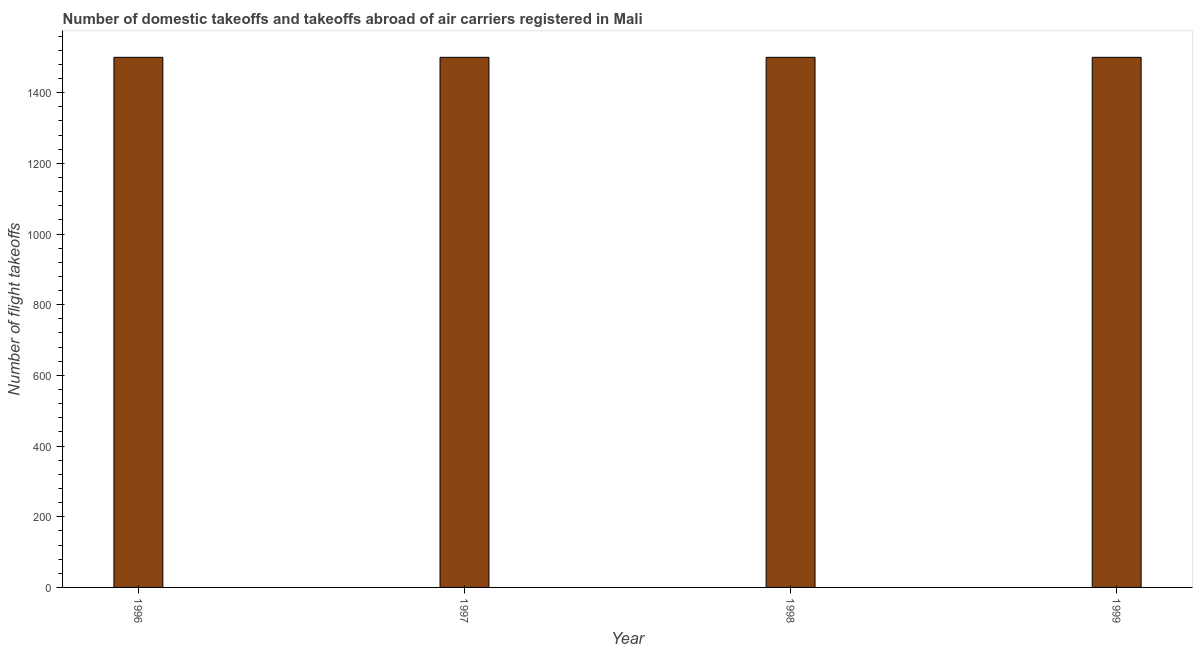Does the graph contain any zero values?
Ensure brevity in your answer.  No. What is the title of the graph?
Provide a short and direct response. Number of domestic takeoffs and takeoffs abroad of air carriers registered in Mali. What is the label or title of the X-axis?
Provide a short and direct response. Year. What is the label or title of the Y-axis?
Provide a short and direct response. Number of flight takeoffs. What is the number of flight takeoffs in 1998?
Keep it short and to the point. 1500. Across all years, what is the maximum number of flight takeoffs?
Your answer should be compact. 1500. Across all years, what is the minimum number of flight takeoffs?
Provide a succinct answer. 1500. In which year was the number of flight takeoffs minimum?
Provide a succinct answer. 1996. What is the sum of the number of flight takeoffs?
Give a very brief answer. 6000. What is the difference between the number of flight takeoffs in 1997 and 1999?
Give a very brief answer. 0. What is the average number of flight takeoffs per year?
Offer a very short reply. 1500. What is the median number of flight takeoffs?
Your answer should be very brief. 1500. Do a majority of the years between 1998 and 1996 (inclusive) have number of flight takeoffs greater than 40 ?
Keep it short and to the point. Yes. Is the number of flight takeoffs in 1996 less than that in 1997?
Your answer should be compact. No. Is the difference between the number of flight takeoffs in 1997 and 1999 greater than the difference between any two years?
Make the answer very short. Yes. What is the difference between the highest and the second highest number of flight takeoffs?
Offer a very short reply. 0. Is the sum of the number of flight takeoffs in 1996 and 1998 greater than the maximum number of flight takeoffs across all years?
Offer a terse response. Yes. What is the difference between the highest and the lowest number of flight takeoffs?
Give a very brief answer. 0. In how many years, is the number of flight takeoffs greater than the average number of flight takeoffs taken over all years?
Make the answer very short. 0. How many years are there in the graph?
Keep it short and to the point. 4. Are the values on the major ticks of Y-axis written in scientific E-notation?
Ensure brevity in your answer.  No. What is the Number of flight takeoffs of 1996?
Your answer should be very brief. 1500. What is the Number of flight takeoffs of 1997?
Provide a short and direct response. 1500. What is the Number of flight takeoffs of 1998?
Offer a terse response. 1500. What is the Number of flight takeoffs in 1999?
Your answer should be compact. 1500. What is the difference between the Number of flight takeoffs in 1996 and 1997?
Offer a very short reply. 0. What is the difference between the Number of flight takeoffs in 1996 and 1998?
Make the answer very short. 0. What is the difference between the Number of flight takeoffs in 1996 and 1999?
Give a very brief answer. 0. What is the difference between the Number of flight takeoffs in 1997 and 1998?
Give a very brief answer. 0. What is the difference between the Number of flight takeoffs in 1997 and 1999?
Offer a terse response. 0. What is the difference between the Number of flight takeoffs in 1998 and 1999?
Provide a succinct answer. 0. What is the ratio of the Number of flight takeoffs in 1996 to that in 1998?
Give a very brief answer. 1. What is the ratio of the Number of flight takeoffs in 1996 to that in 1999?
Provide a short and direct response. 1. What is the ratio of the Number of flight takeoffs in 1998 to that in 1999?
Offer a terse response. 1. 